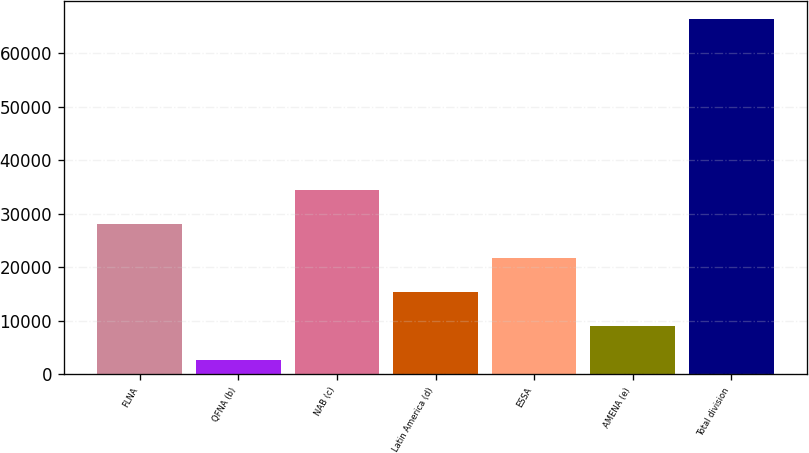Convert chart to OTSL. <chart><loc_0><loc_0><loc_500><loc_500><bar_chart><fcel>FLNA<fcel>QFNA (b)<fcel>NAB (c)<fcel>Latin America (d)<fcel>ESSA<fcel>AMENA (e)<fcel>Total division<nl><fcel>28133.2<fcel>2612<fcel>34513.5<fcel>15372.6<fcel>21752.9<fcel>8992.3<fcel>66415<nl></chart> 